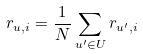Convert formula to latex. <formula><loc_0><loc_0><loc_500><loc_500>r _ { u , i } = \frac { 1 } { N } \sum _ { u ^ { \prime } \in U } r _ { u ^ { \prime } , i }</formula> 